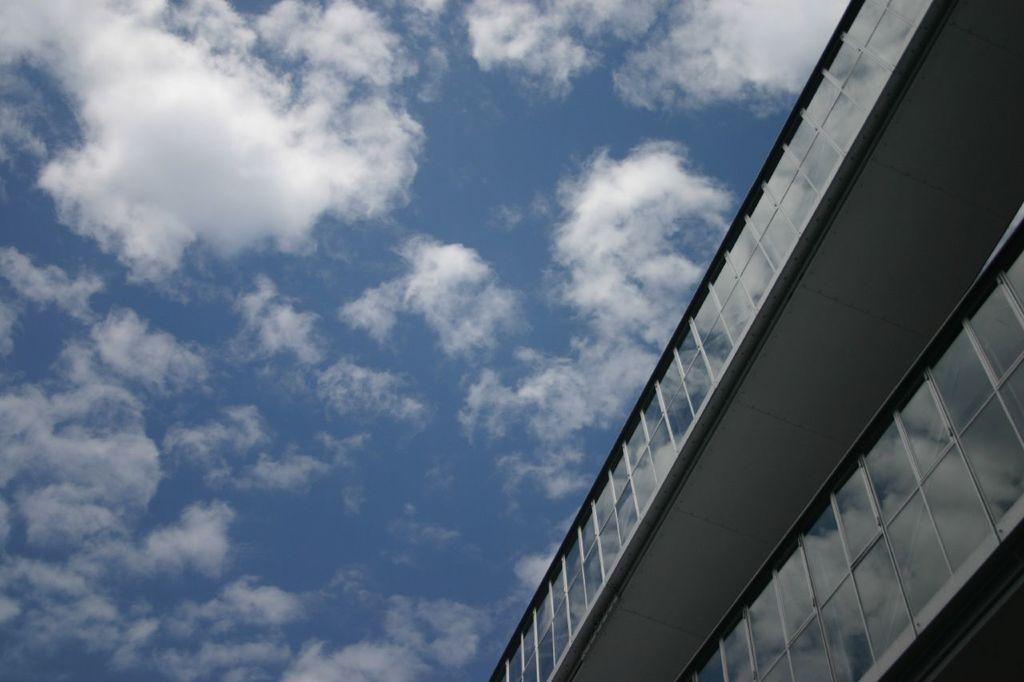What type of structure is in the image? There is a building in the image. What feature can be seen on the building? The building has glass windows. What can be seen in the background of the image? Sky is visible in the background of the image. What is present in the sky? Clouds are present in the sky. What type of writing can be seen on the building in the image? There is no writing visible on the building in the image. How are the waves used in the image? There are no waves present in the image. 